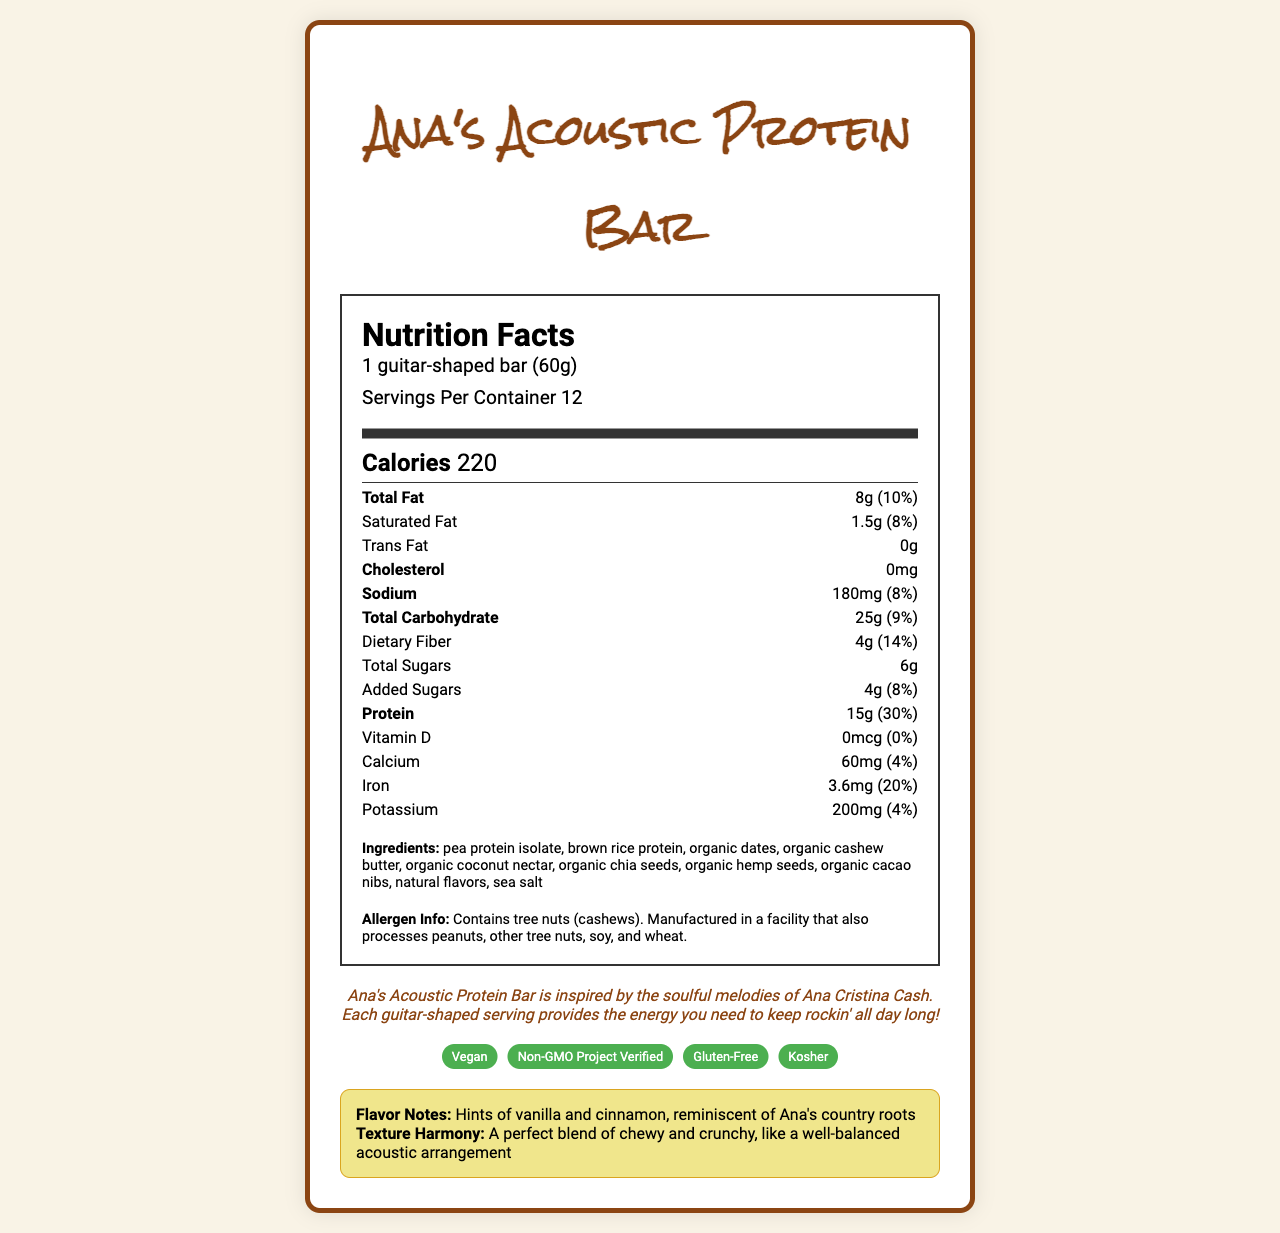what is the serving size of Ana's Acoustic Protein Bar? The serving size is mentioned in the nutrition label section under "serving info".
Answer: 1 guitar-shaped bar (60g) how many calories does one guitar-shaped bar contain? The calorie count is listed under the "Calorie Info" section of the nutrition label.
Answer: 220 how much protein does the bar provide per serving? The protein content is detailed in the "nutrient info" section, showing 15g per serving.
Answer: 15g which ingredients are used in Ana's Acoustic Protein Bar? The ingredients are listed in the "Ingredients" section of the document.
Answer: pea protein isolate, brown rice protein, organic dates, organic cashew butter, organic coconut nectar, organic chia seeds, organic hemp seeds, organic cacao nibs, natural flavors, sea salt does the bar contain any tree nuts? The allergen information specifies that the product contains tree nuts (cashews).
Answer: Yes how many servings are in one container? The number of servings per container is provided in the serving information section: "Servings Per Container 12."
Answer: 12 what is the amount of dietary fiber per serving? The dietary fiber amount is shown in the "nutrient info" section as 4g per serving.
Answer: 4g which of the following certifications does Ana's Acoustic Protein Bar have? A. USDA Organic B. Non-GMO Project Verified C. Fair Trade Certified D. Gluten-Free The certifications listed in the document include "Non-GMO Project Verified" and "Gluten-Free," among others.
Answer: B. Non-GMO Project Verified D. Gluten-Free how much iron does each bar provide? A. 1mg B. 3.6mg C. 5mg D. 2mg The iron content is listed in the "nutrient info" section as 3.6mg.
Answer: B. 3.6mg is the bar certified kosher? The certification section includes "Kosher."
Answer: Yes what are the main flavor notes described in the musical notes section? The musical notes section describes the flavor notes as "Hints of vanilla and cinnamon," reminiscent of Ana's country roots.
Answer: Hints of vanilla and cinnamon describe the texture of the bar according to the document. The musical notes describe the texture harmony as a perfect blend of chewy and crunchy, similar to a well-balanced acoustic arrangement.
Answer: A perfect blend of chewy and crunchy what is the carb-to-fat ratio in Ana's Acoustic Protein Bar? The document provides the amounts of total carbohydrate and total fat but does not provide a direct ratio or enough information to calculate it intuitively.
Answer: Not enough information summarize the main idea of this document. The document is an informative label for Ana's Acoustic Protein Bar, including detailed nutrition information, ingredient list, allergen warnings, brand statement, and various certifications. It also ties the product to the musical inspiration of Ana Cristina Cash, describing the flavor and texture with musical analogies.
Answer: The document details the nutrition facts, ingredients, allergen information, and certifications of Ana's Acoustic Protein Bar, a vegan protein bar shaped like a guitar. Inspired by Ana Cristina Cash's music, the bar offers a blend of textures and flavors with musical notes described in the document, along with its health-related benefits and certifications. 